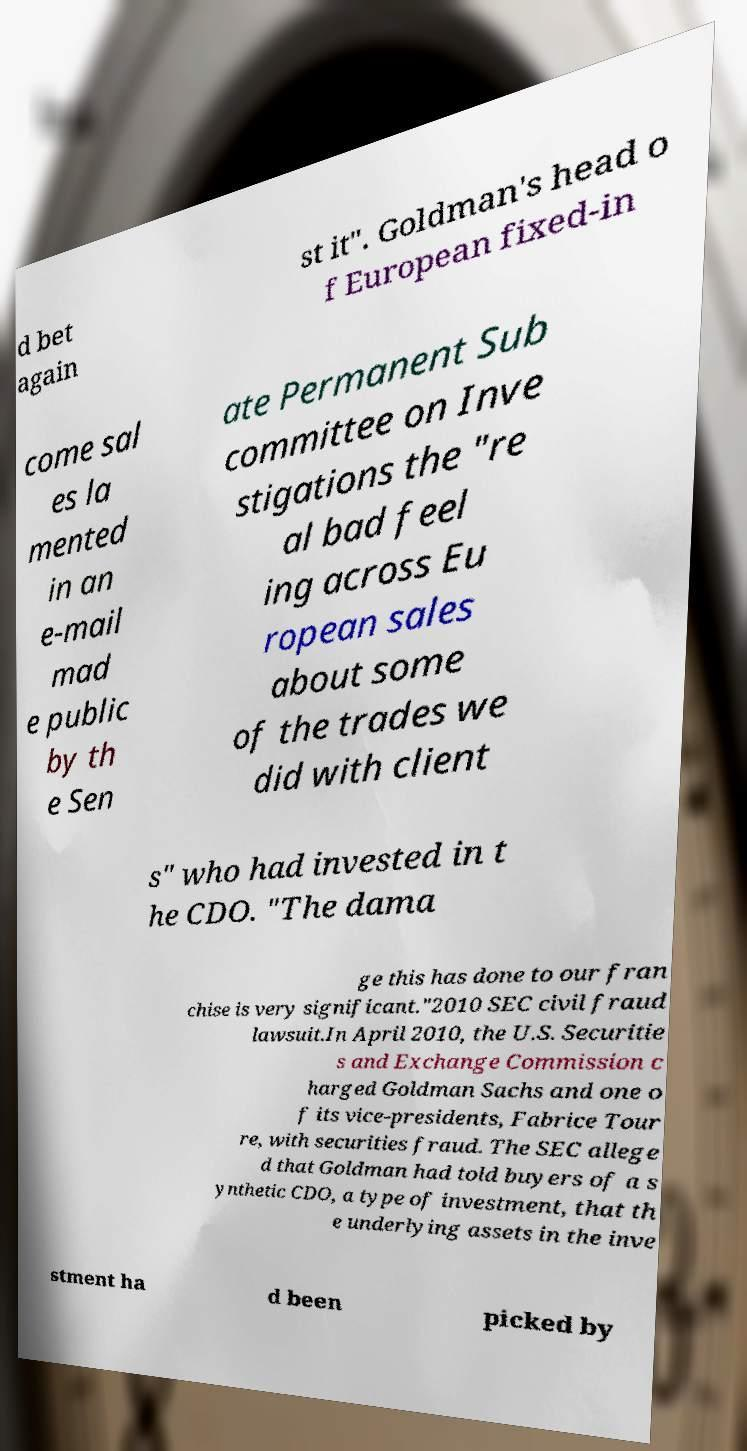For documentation purposes, I need the text within this image transcribed. Could you provide that? d bet again st it". Goldman's head o f European fixed-in come sal es la mented in an e-mail mad e public by th e Sen ate Permanent Sub committee on Inve stigations the "re al bad feel ing across Eu ropean sales about some of the trades we did with client s" who had invested in t he CDO. "The dama ge this has done to our fran chise is very significant."2010 SEC civil fraud lawsuit.In April 2010, the U.S. Securitie s and Exchange Commission c harged Goldman Sachs and one o f its vice-presidents, Fabrice Tour re, with securities fraud. The SEC allege d that Goldman had told buyers of a s ynthetic CDO, a type of investment, that th e underlying assets in the inve stment ha d been picked by 